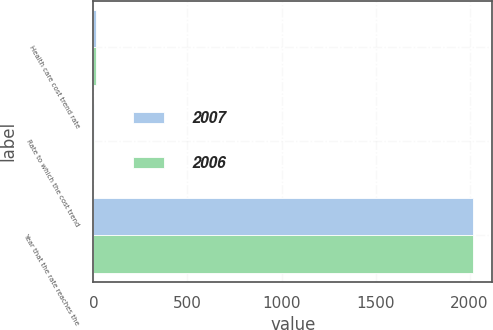Convert chart. <chart><loc_0><loc_0><loc_500><loc_500><stacked_bar_chart><ecel><fcel>Health care cost trend rate<fcel>Rate to which the cost trend<fcel>Year that the rate reaches the<nl><fcel>2007<fcel>11<fcel>5<fcel>2019<nl><fcel>2006<fcel>11<fcel>5<fcel>2018<nl></chart> 